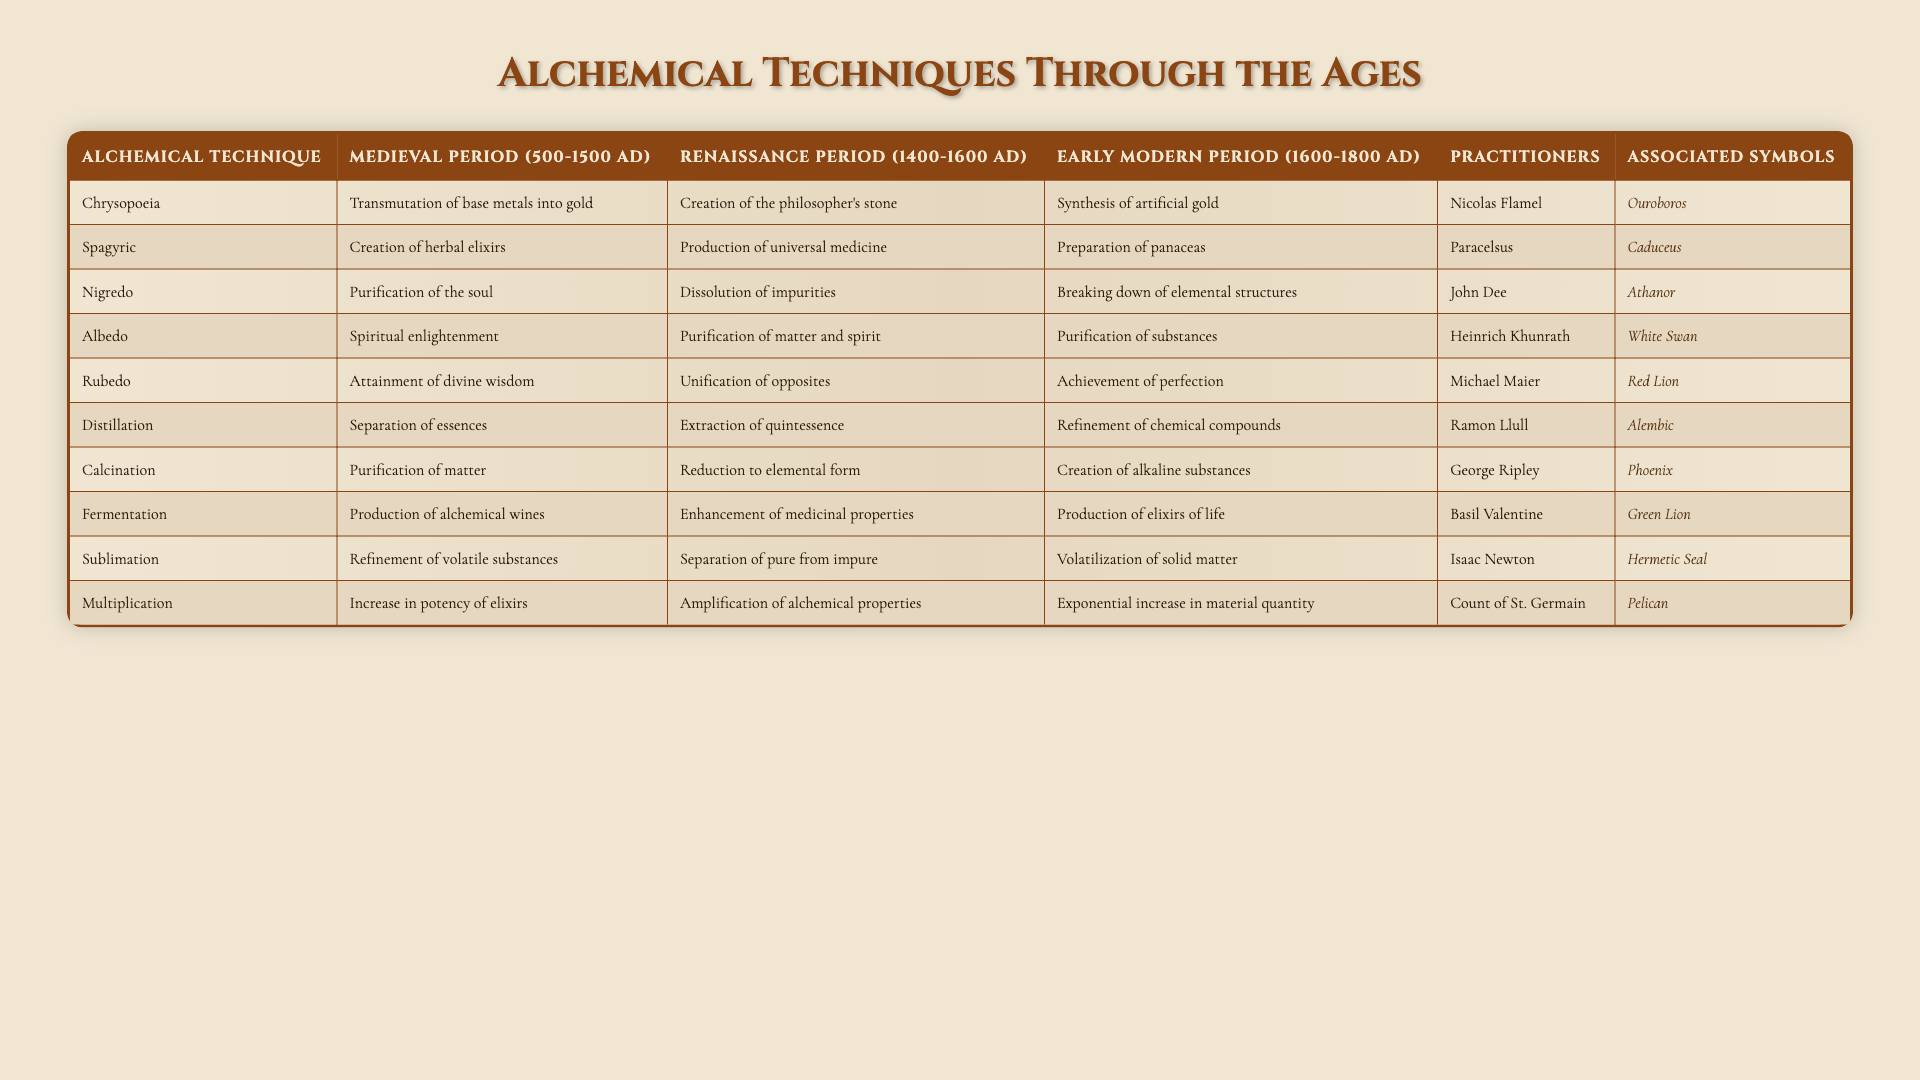What is the effect associated with Chrysopoeia in the Medieval Period? According to the table, the effect associated with Chrysopoeia during the Medieval Period is the "Transmutation of base metals into gold."
Answer: Transmutation of base metals into gold Which alchemical technique focuses on the creation of universal medicine during the Renaissance Period? From the table, the technique that focuses on the creation of universal medicine in the Renaissance Period is "Spagyric."
Answer: Spagyric In which period did practitioners attempt to synthesize artificial gold? The table indicates that the synthesis of artificial gold occurred in the Early Modern Period (1600-1800 AD).
Answer: Early Modern Period Does the technique of Fermentation appear in all historical periods listed? Looking at the table, Fermentation is mentioned only in the Medieval Period and Early Modern Period, but not in the Renaissance Period. Therefore, the statement is false.
Answer: No What was the difference in the goal of the Rubedo technique between the Medieval and Renaissance periods? In the Medieval Period, Rubedo was associated with "Attainment of divine wisdom," while in the Renaissance it was about "Unification of opposites." This shows a shift from a spiritual goal to a more philosophical one.
Answer: Spiritual to philosophical shift Which alchemical technique was practiced by both John Dee and Isaac Newton? According to the table, both John Dee and Isaac Newton were associated with the technique of "Distillation."
Answer: Distillation Calculate the total number of effects mentioned for the technique of Sublimation across all periods. The table shows that Sublimation has effects in the Medieval Period (Refinement of volatile substances), Renaissance Period (Separation of pure from impure), and Early Modern Period (Volatilization of solid matter). This gives us a total of 3 effects.
Answer: 3 What is the associated symbol for the practitioners of Nicolas Flamel? The table indicates that the symbol associated with Nicolas Flamel is "Ouroboros."
Answer: Ouroboros Is there any alchemical technique that increases potency, and if so, in which period did it appear? The technique that increases potency is "Multiplication," which is listed in the Medieval Period. Therefore, this technique focuses on enhancing elixir strengths during that time.
Answer: Yes, in the Medieval Period Identify the differences in associated symbols for Spagyric and Fermentation techniques. Spagyric is associated with the "Caduceus," whereas Fermentation is linked to the symbol "Phoenix." This highlights a difference in the themes they represent, with Caduceus symbolizing healing and Phoenix representing rebirth.
Answer: Caduceus for Spagyric, Phoenix for Fermentation 